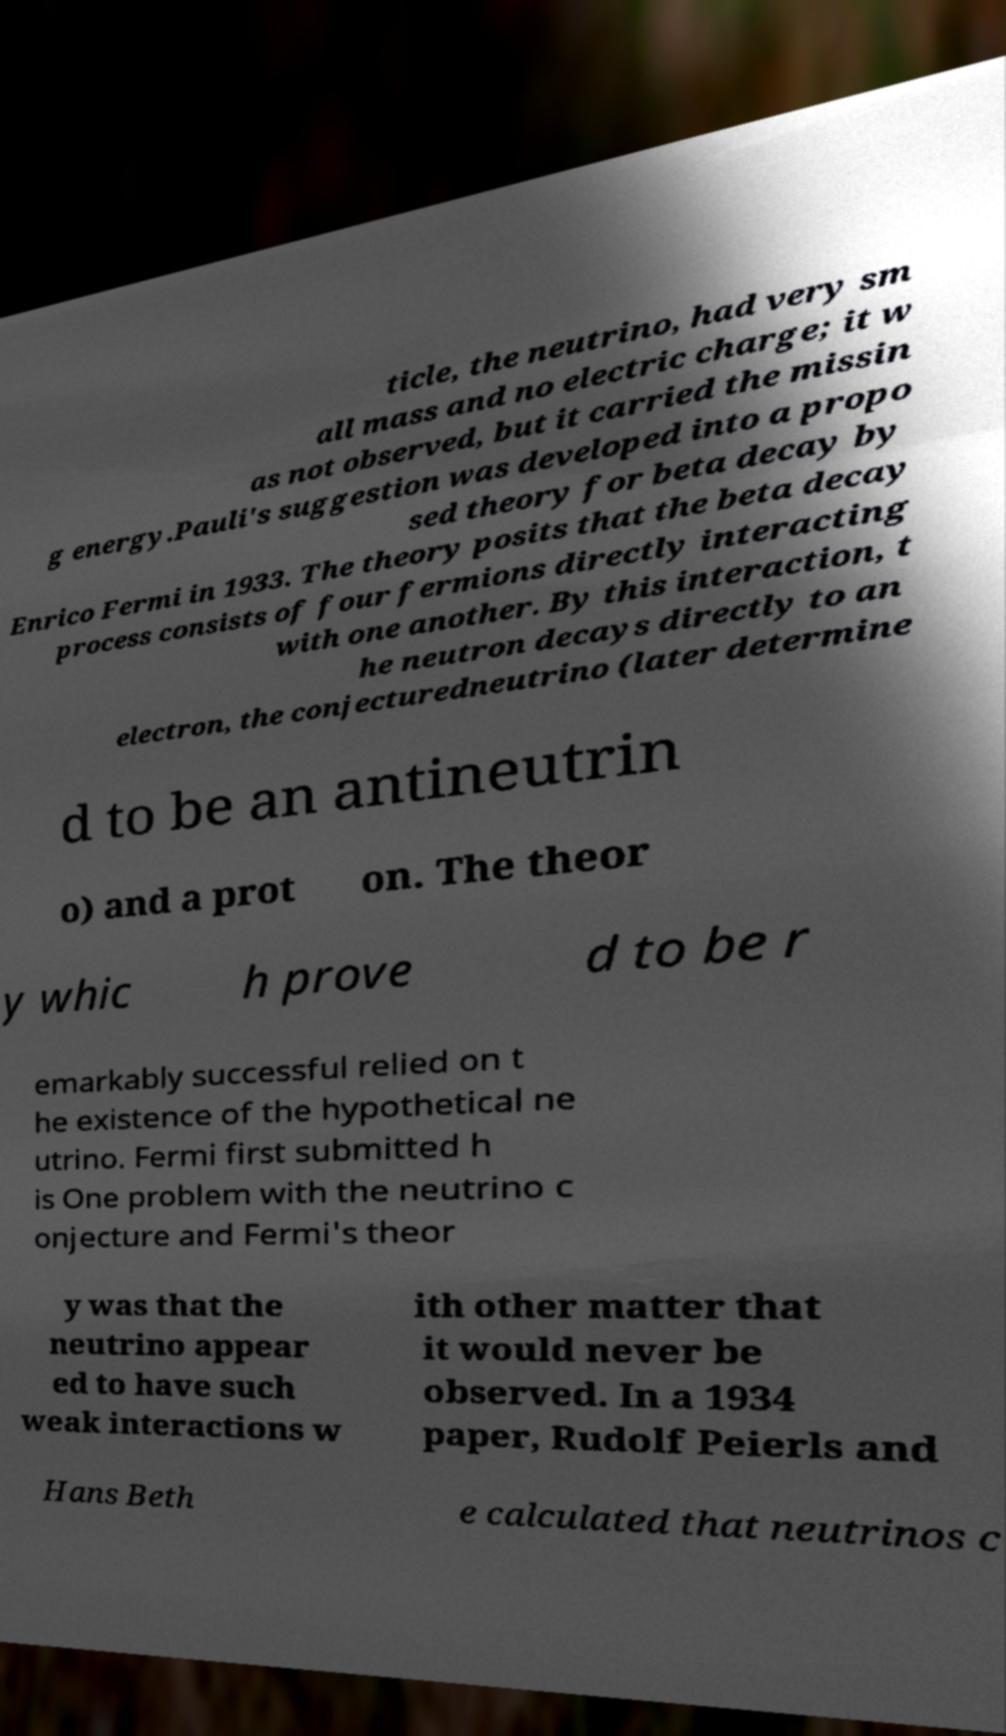Could you extract and type out the text from this image? ticle, the neutrino, had very sm all mass and no electric charge; it w as not observed, but it carried the missin g energy.Pauli's suggestion was developed into a propo sed theory for beta decay by Enrico Fermi in 1933. The theory posits that the beta decay process consists of four fermions directly interacting with one another. By this interaction, t he neutron decays directly to an electron, the conjecturedneutrino (later determine d to be an antineutrin o) and a prot on. The theor y whic h prove d to be r emarkably successful relied on t he existence of the hypothetical ne utrino. Fermi first submitted h is One problem with the neutrino c onjecture and Fermi's theor y was that the neutrino appear ed to have such weak interactions w ith other matter that it would never be observed. In a 1934 paper, Rudolf Peierls and Hans Beth e calculated that neutrinos c 